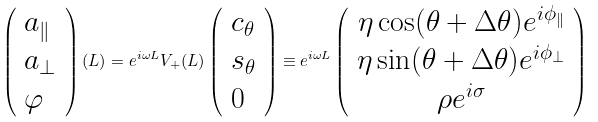<formula> <loc_0><loc_0><loc_500><loc_500>\left ( \begin{array} { l } a _ { \| } \\ a _ { \perp } \\ \varphi \end{array} \right ) ( L ) = e ^ { i \omega L } V _ { + } ( L ) \left ( \begin{array} { l } c _ { \theta } \\ s _ { \theta } \\ 0 \end{array} \right ) \equiv e ^ { i \omega L } \left ( \begin{array} { c } \eta \cos ( \theta + \Delta \theta ) e ^ { i \phi _ { \| } } \\ \eta \sin ( \theta + \Delta \theta ) e ^ { i \phi _ { \perp } } \\ \rho e ^ { i \sigma } \end{array} \right )</formula> 